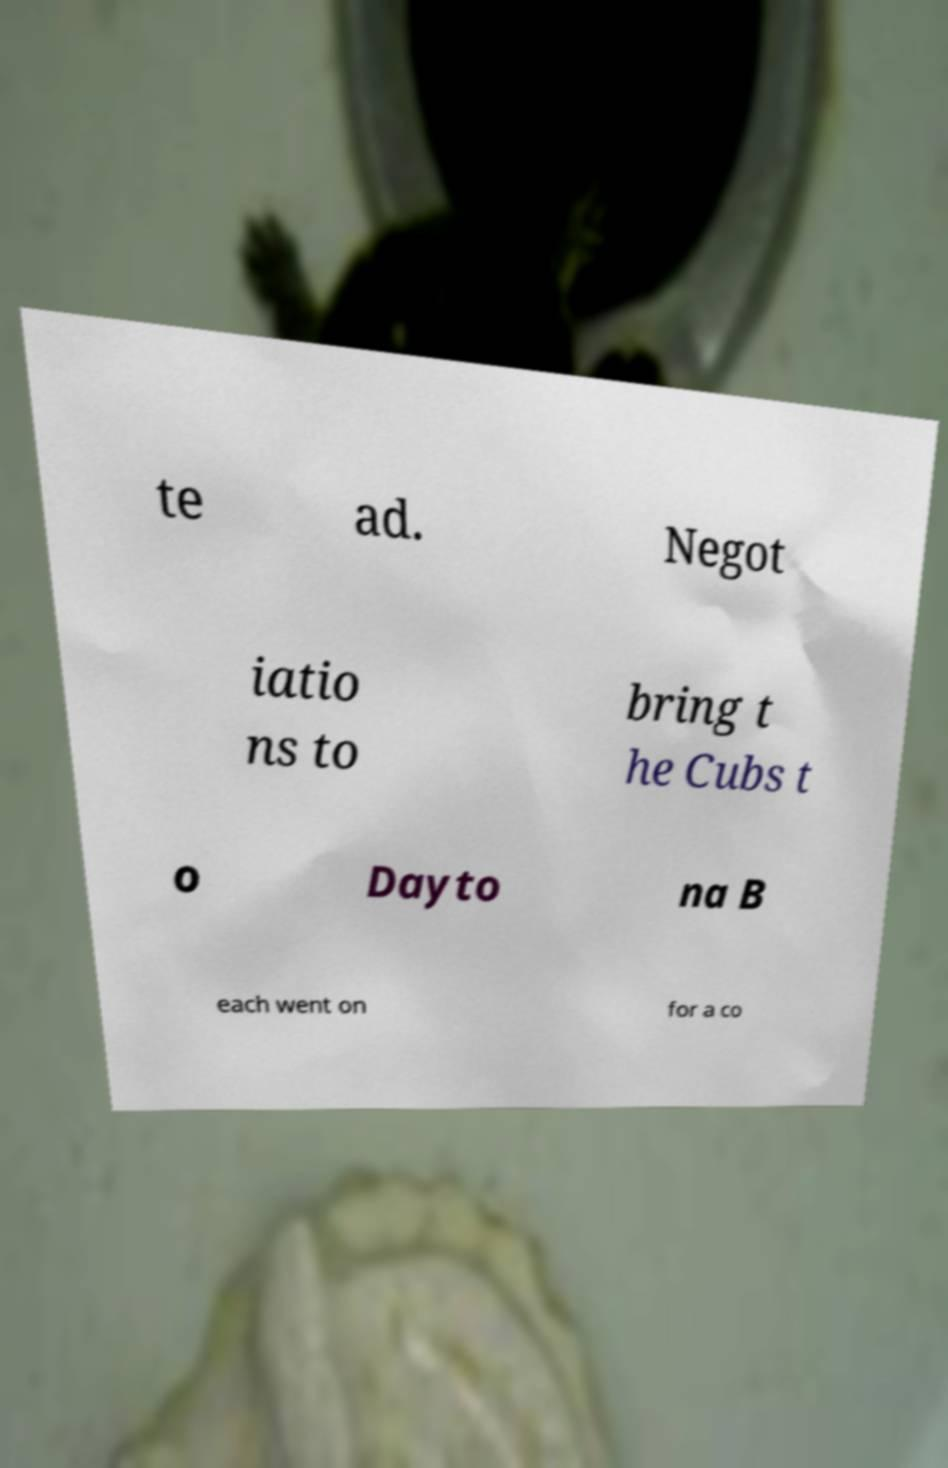What messages or text are displayed in this image? I need them in a readable, typed format. te ad. Negot iatio ns to bring t he Cubs t o Dayto na B each went on for a co 